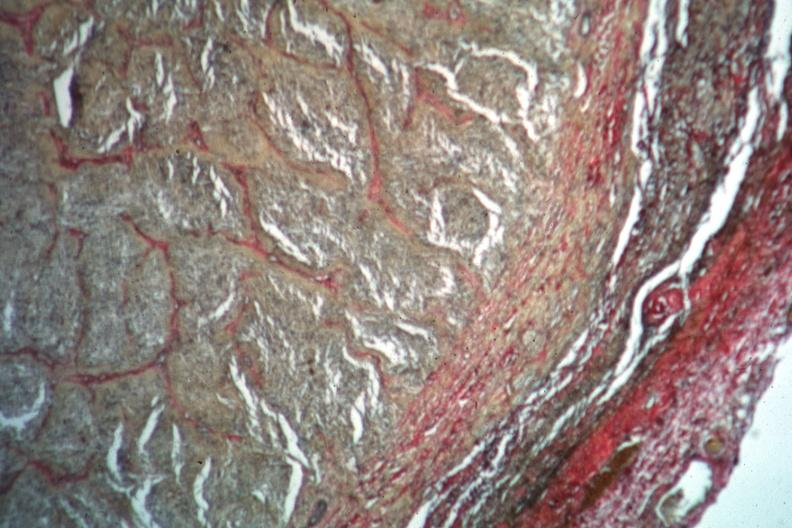s glioma present?
Answer the question using a single word or phrase. Yes 